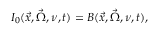Convert formula to latex. <formula><loc_0><loc_0><loc_500><loc_500>I _ { 0 } ( \vec { x } , \vec { \Omega } , \nu , t ) = B ( \vec { x } , \vec { \Omega } , \nu , t ) ,</formula> 